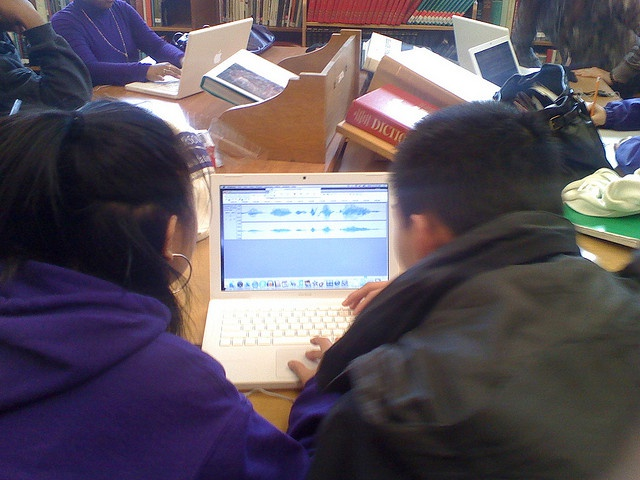Describe the objects in this image and their specific colors. I can see people in brown, black, and gray tones, people in brown, navy, black, purple, and gray tones, laptop in brown, white, lightblue, and tan tones, book in brown, white, and gray tones, and people in brown, black, gray, and darkblue tones in this image. 